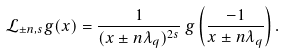<formula> <loc_0><loc_0><loc_500><loc_500>\mathcal { L } _ { \pm n , s } g ( x ) = \frac { 1 } { ( x \pm n \lambda _ { q } ) ^ { 2 s } } \, g \left ( \frac { - 1 } { x \pm n \lambda _ { q } } \right ) .</formula> 